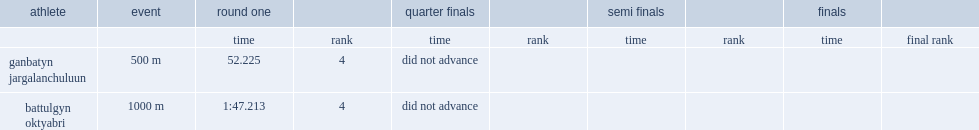What was the rank of battulgyn oktyabri in the 1000m metres? 4.0. Could you parse the entire table as a dict? {'header': ['athlete', 'event', 'round one', '', 'quarter finals', '', 'semi finals', '', 'finals', ''], 'rows': [['', '', 'time', 'rank', 'time', 'rank', 'time', 'rank', 'time', 'final rank'], ['ganbatyn jargalanchuluun', '500 m', '52.225', '4', 'did not advance', '', '', '', '', ''], ['battulgyn oktyabri', '1000 m', '1:47.213', '4', 'did not advance', '', '', '', '', '']]} 